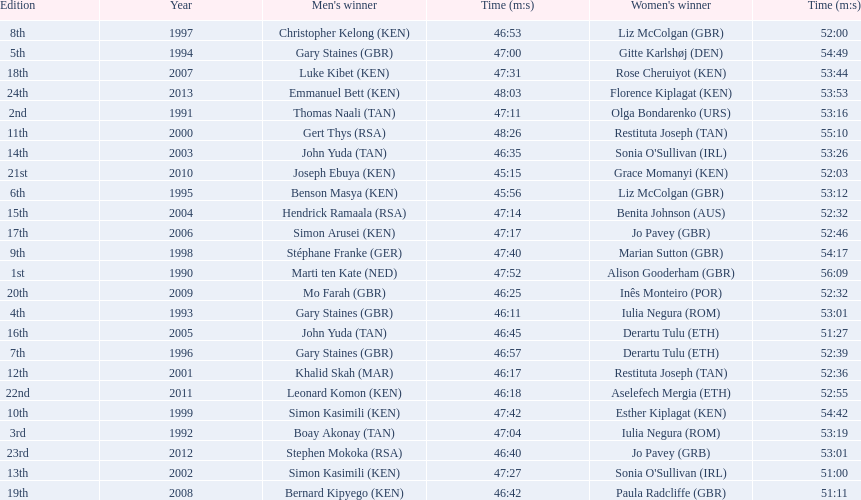Which of the runner in the great south run were women? Alison Gooderham (GBR), Olga Bondarenko (URS), Iulia Negura (ROM), Iulia Negura (ROM), Gitte Karlshøj (DEN), Liz McColgan (GBR), Derartu Tulu (ETH), Liz McColgan (GBR), Marian Sutton (GBR), Esther Kiplagat (KEN), Restituta Joseph (TAN), Restituta Joseph (TAN), Sonia O'Sullivan (IRL), Sonia O'Sullivan (IRL), Benita Johnson (AUS), Derartu Tulu (ETH), Jo Pavey (GBR), Rose Cheruiyot (KEN), Paula Radcliffe (GBR), Inês Monteiro (POR), Grace Momanyi (KEN), Aselefech Mergia (ETH), Jo Pavey (GRB), Florence Kiplagat (KEN). Of those women, which ones had a time of at least 53 minutes? Alison Gooderham (GBR), Olga Bondarenko (URS), Iulia Negura (ROM), Iulia Negura (ROM), Gitte Karlshøj (DEN), Liz McColgan (GBR), Marian Sutton (GBR), Esther Kiplagat (KEN), Restituta Joseph (TAN), Sonia O'Sullivan (IRL), Rose Cheruiyot (KEN), Jo Pavey (GRB), Florence Kiplagat (KEN). Between those women, which ones did not go over 53 minutes? Olga Bondarenko (URS), Iulia Negura (ROM), Iulia Negura (ROM), Liz McColgan (GBR), Sonia O'Sullivan (IRL), Rose Cheruiyot (KEN), Jo Pavey (GRB), Florence Kiplagat (KEN). Of those 8, what were the three slowest times? Sonia O'Sullivan (IRL), Rose Cheruiyot (KEN), Florence Kiplagat (KEN). Between only those 3 women, which runner had the fastest time? Sonia O'Sullivan (IRL). What was this women's time? 53:26. 